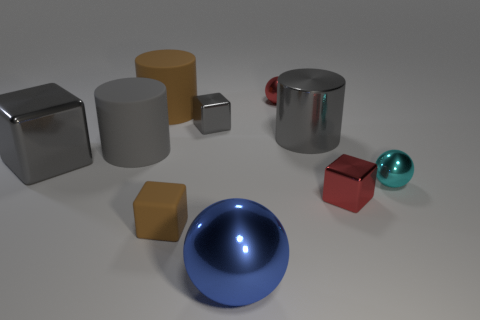Can you describe the objects in the foreground? Certainly! In the foreground, there is a prominent blue sphere with a glossy finish. In close proximity, there's also a matte gold-colored cube. The two objects stand out due to their color and finish, contrasting with the neutral background. 